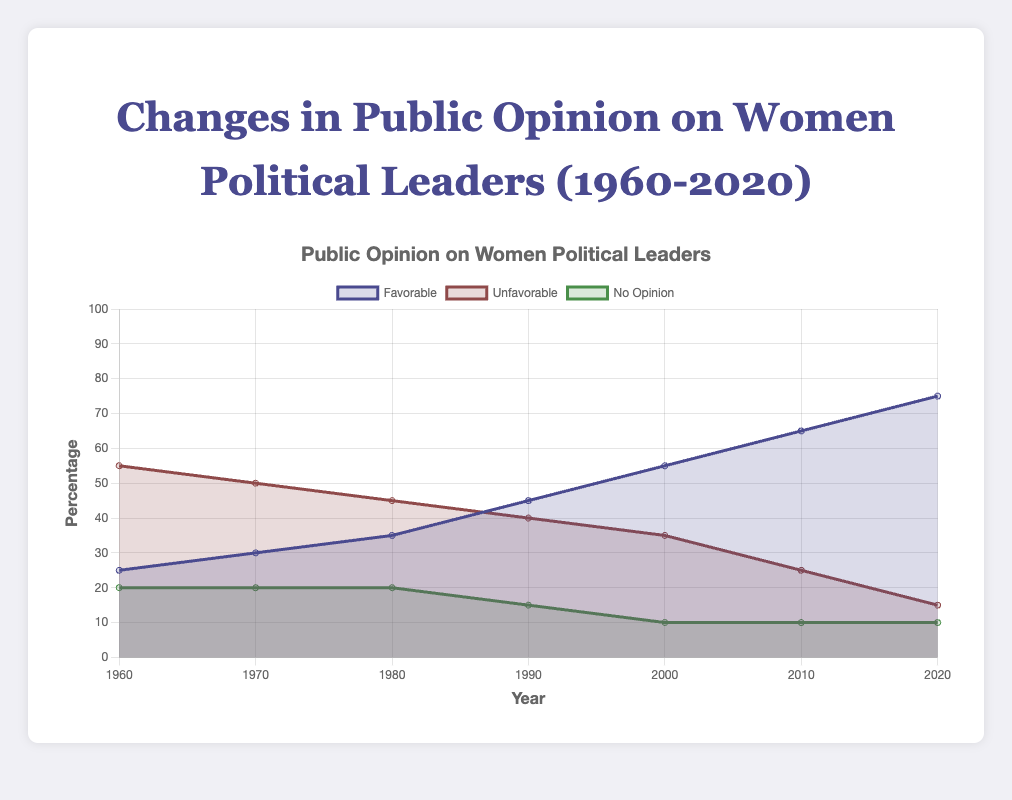What year marks the highest percentage of favorable public opinion on women political leaders? By looking at the line representing favorable opinions, we find the highest point is in 2020 with 75%.
Answer: 2020 In which year did the unfavorable opinion drop below 50% for the first time? By following the trajectory of the unfavorable line, it drops below 50% for the first time in 1980.
Answer: 1980 What is the sum of the favorable and unfavorable percentages in 2000? From the figure, favorable is 55% and unfavorable is 35%. Adding them together gives 55 + 35 = 90%.
Answer: 90% How much did the favorable opinion increase from 1960 to 2020? The favorable percentage in 1960 was 25% and in 2020 it was 75%, so the increase is 75 - 25 = 50%.
Answer: 50% What is the average percentage of no opinion from 1960 to 2020? The no-opinion percentages are [20, 20, 20, 15, 10, 10, 10]. Adding them gives 105, and the average is 105 / 7 ≈ 15%.
Answer: 15% In which year was the difference between the favorable and unfavorable opinions the largest? The differences are calculated for each year and the largest difference is in 2020 with 75% favorable and 15% unfavorable, giving a difference of 75 - 15 = 60%.
Answer: 2020 How many years did it take for the favorable opinion to double from its 1960 value? The favorable opinion was 25% in 1960. Doubling this is 50%. It first reaches 50% in 2000. The number of years from 1960 to 2000 is 40.
Answer: 40 In which decade did the no-opinion percentage decrease for the first time? No-opinion percentage goes from 20% to 20% in the 1960s, remains at 20% in the 1970s, and decreases to 15% in the 1980s. So, it's in the 1980s.
Answer: 1980s 